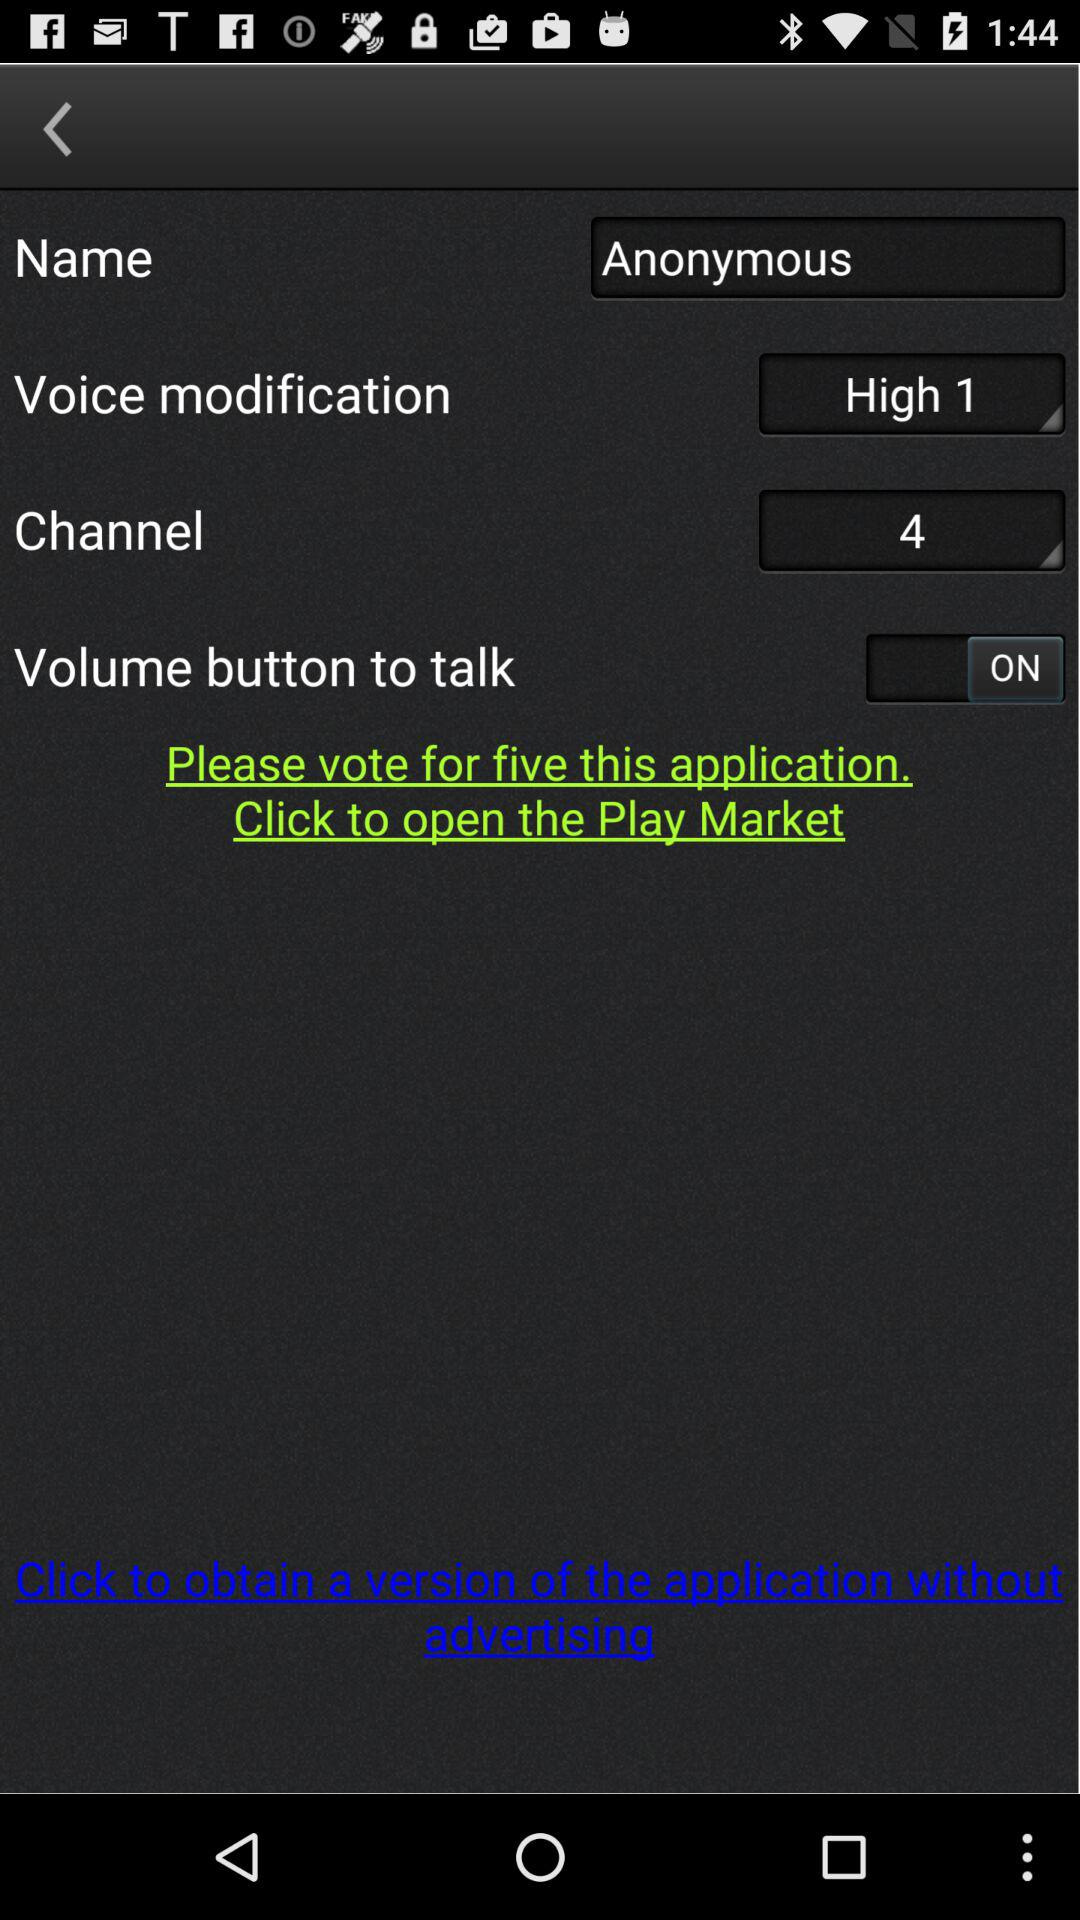What is the channel number? The channel number is 4. 